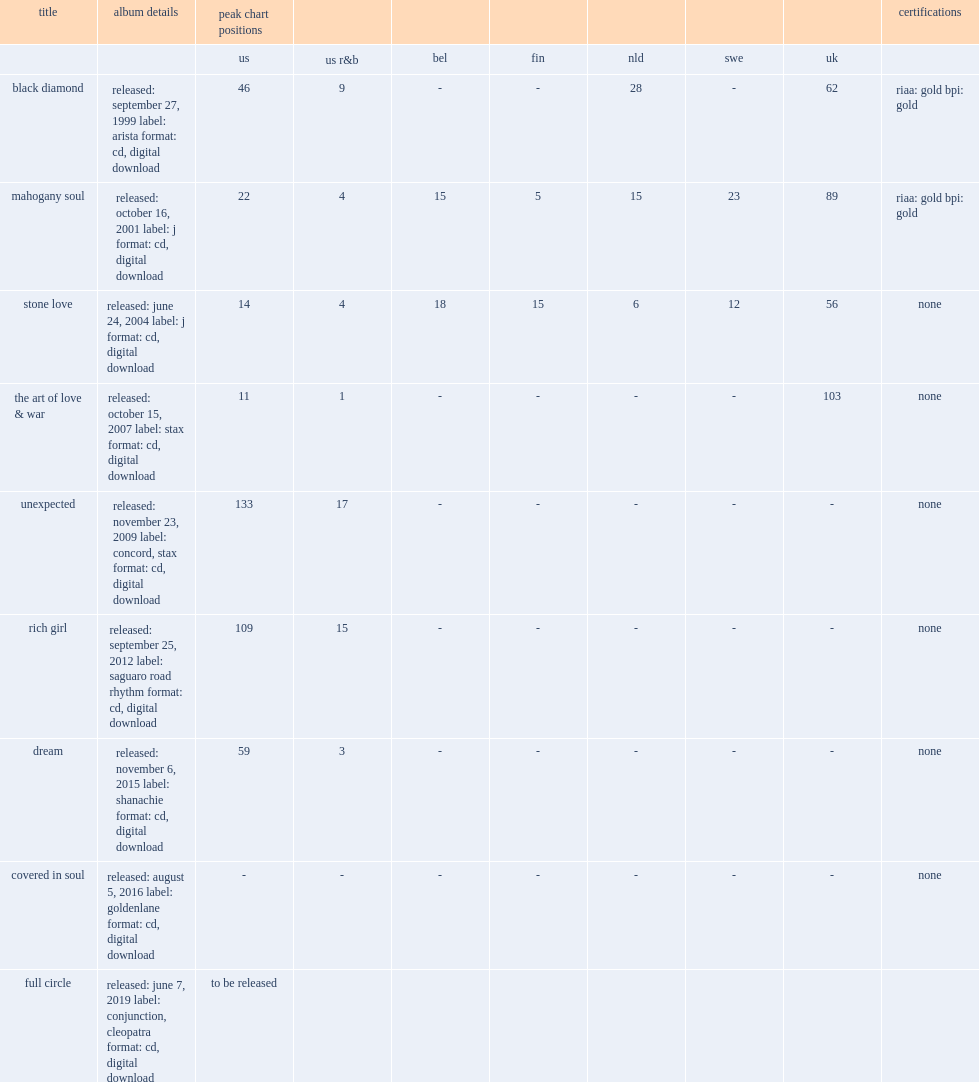What is the peak chart position for "unexpected" album on the us? 133.0. 